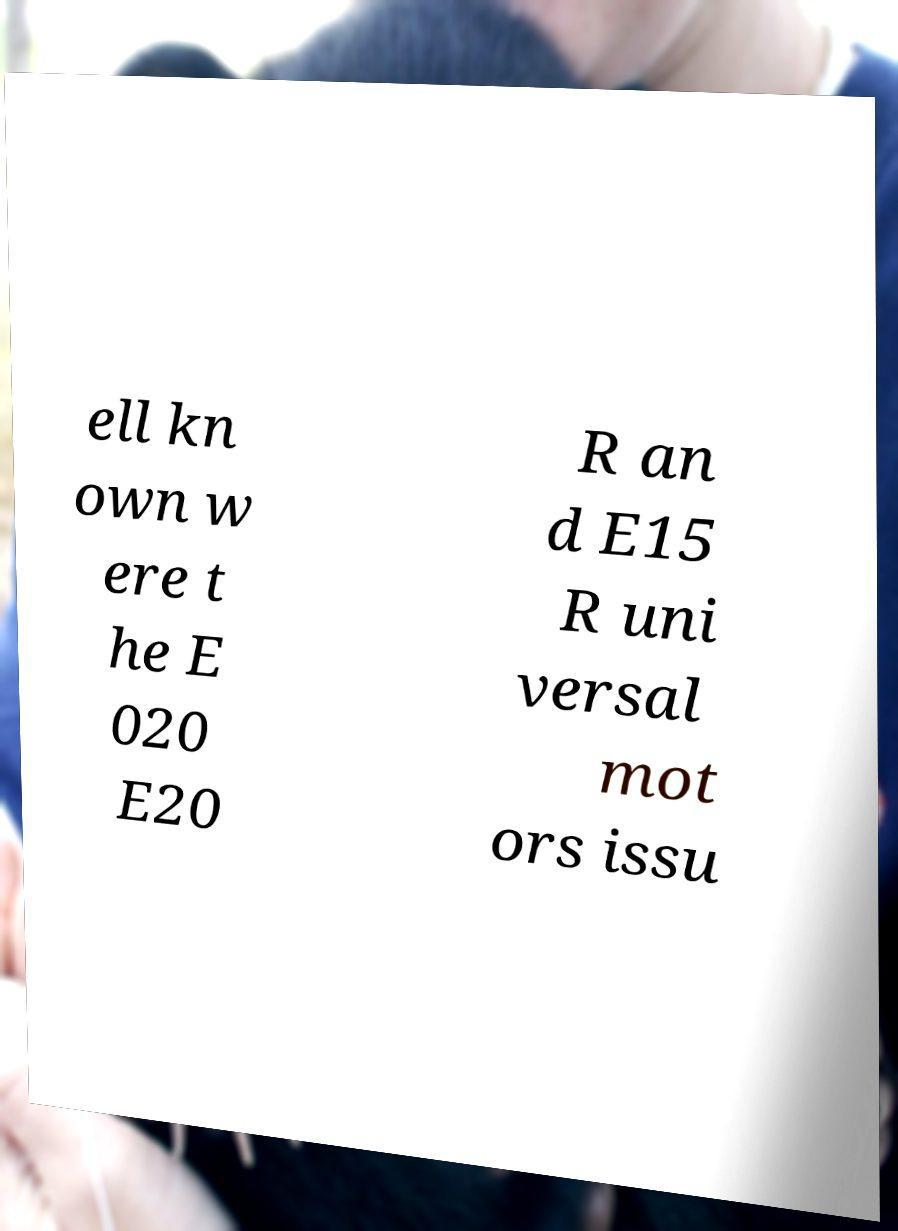Can you read and provide the text displayed in the image?This photo seems to have some interesting text. Can you extract and type it out for me? ell kn own w ere t he E 020 E20 R an d E15 R uni versal mot ors issu 